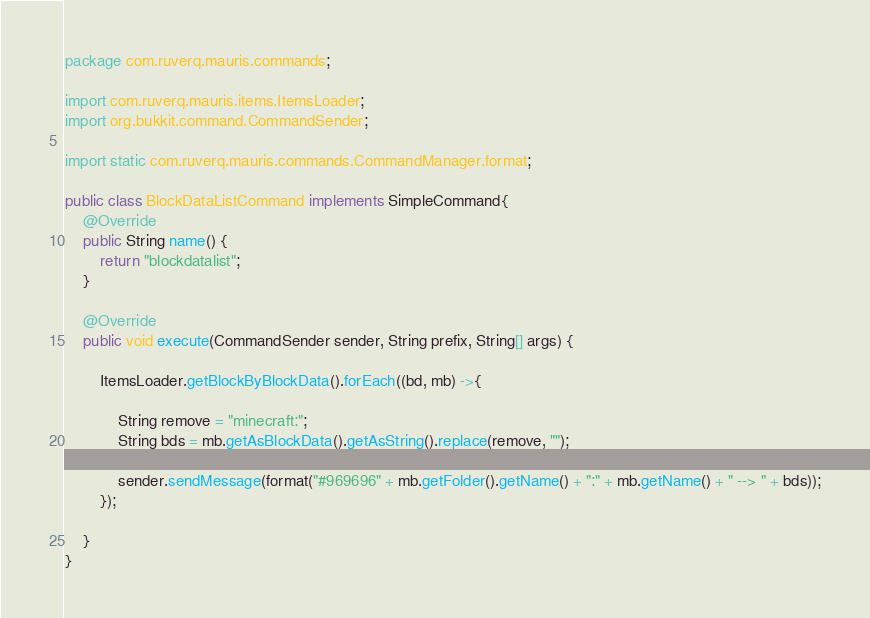Convert code to text. <code><loc_0><loc_0><loc_500><loc_500><_Java_>package com.ruverq.mauris.commands;

import com.ruverq.mauris.items.ItemsLoader;
import org.bukkit.command.CommandSender;

import static com.ruverq.mauris.commands.CommandManager.format;

public class BlockDataListCommand implements SimpleCommand{
    @Override
    public String name() {
        return "blockdatalist";
    }

    @Override
    public void execute(CommandSender sender, String prefix, String[] args) {

        ItemsLoader.getBlockByBlockData().forEach((bd, mb) ->{

            String remove = "minecraft:";
            String bds = mb.getAsBlockData().getAsString().replace(remove, "");

            sender.sendMessage(format("#969696" + mb.getFolder().getName() + ":" + mb.getName() + " --> " + bds));
        });

    }
}
</code> 